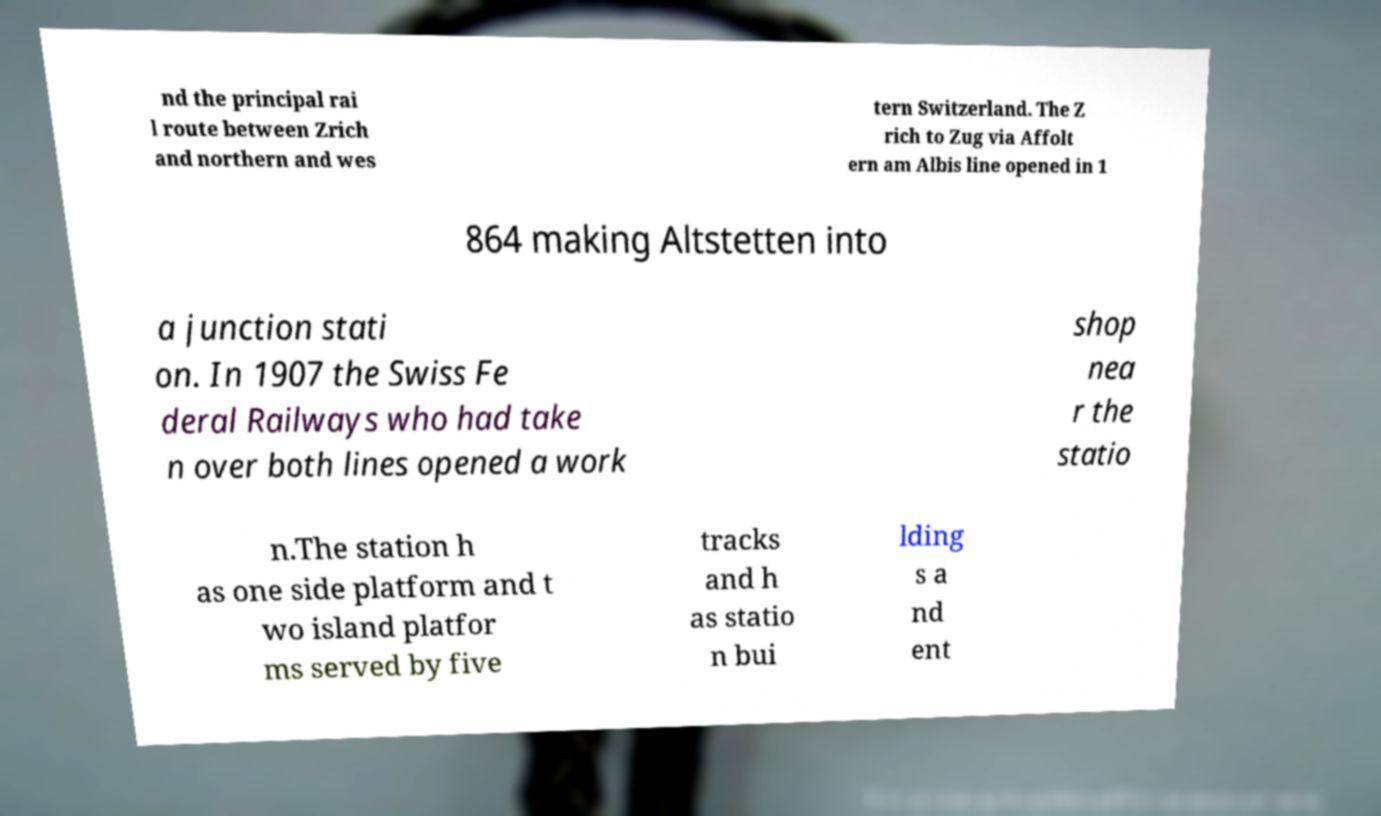Can you read and provide the text displayed in the image?This photo seems to have some interesting text. Can you extract and type it out for me? nd the principal rai l route between Zrich and northern and wes tern Switzerland. The Z rich to Zug via Affolt ern am Albis line opened in 1 864 making Altstetten into a junction stati on. In 1907 the Swiss Fe deral Railways who had take n over both lines opened a work shop nea r the statio n.The station h as one side platform and t wo island platfor ms served by five tracks and h as statio n bui lding s a nd ent 